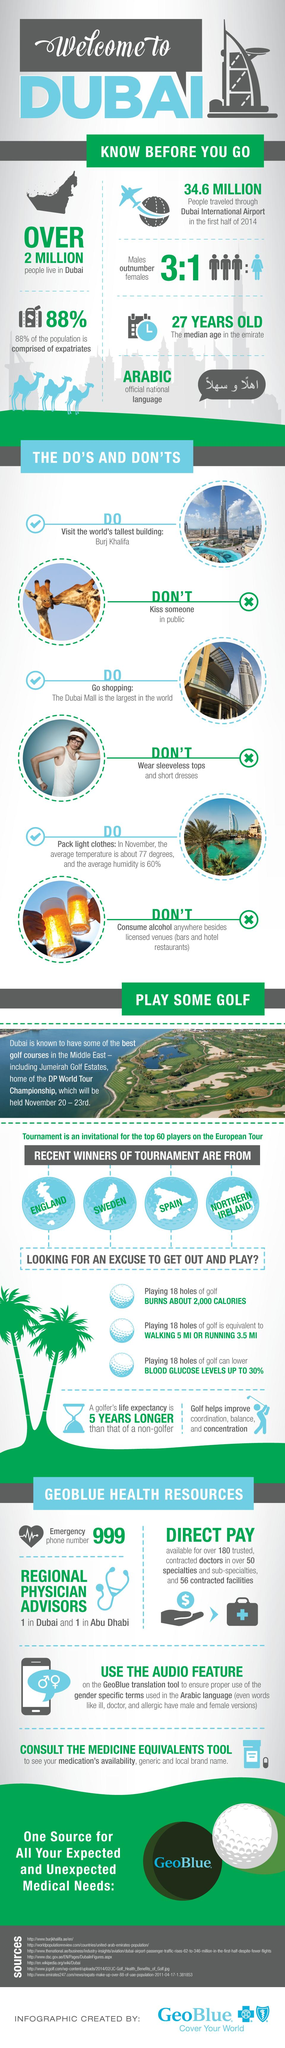Give some essential details in this illustration. In Dubai, it is prohibited to wear sleeveless tops and short dresses. If a sample of 4 people from Dubai is taken, then 3 of them are male. The number of females in a sample of 4 people taken in Dubai is 1. The infographic contains three dos that are listed. According to a recent survey, approximately 12% of the population in Dubai is comprised of individuals who are from Dubai itself. 